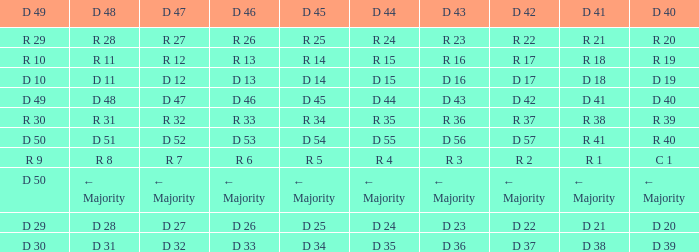Write the full table. {'header': ['D 49', 'D 48', 'D 47', 'D 46', 'D 45', 'D 44', 'D 43', 'D 42', 'D 41', 'D 40'], 'rows': [['R 29', 'R 28', 'R 27', 'R 26', 'R 25', 'R 24', 'R 23', 'R 22', 'R 21', 'R 20'], ['R 10', 'R 11', 'R 12', 'R 13', 'R 14', 'R 15', 'R 16', 'R 17', 'R 18', 'R 19'], ['D 10', 'D 11', 'D 12', 'D 13', 'D 14', 'D 15', 'D 16', 'D 17', 'D 18', 'D 19'], ['D 49', 'D 48', 'D 47', 'D 46', 'D 45', 'D 44', 'D 43', 'D 42', 'D 41', 'D 40'], ['R 30', 'R 31', 'R 32', 'R 33', 'R 34', 'R 35', 'R 36', 'R 37', 'R 38', 'R 39'], ['D 50', 'D 51', 'D 52', 'D 53', 'D 54', 'D 55', 'D 56', 'D 57', 'R 41', 'R 40'], ['R 9', 'R 8', 'R 7', 'R 6', 'R 5', 'R 4', 'R 3', 'R 2', 'R 1', 'C 1'], ['D 50', '← Majority', '← Majority', '← Majority', '← Majority', '← Majority', '← Majority', '← Majority', '← Majority', '← Majority'], ['D 29', 'D 28', 'D 27', 'D 26', 'D 25', 'D 24', 'D 23', 'D 22', 'D 21', 'D 20'], ['D 30', 'D 31', 'D 32', 'D 33', 'D 34', 'D 35', 'D 36', 'D 37', 'D 38', 'D 39']]} I want the D 40 with D 44 of d 15 D 19. 